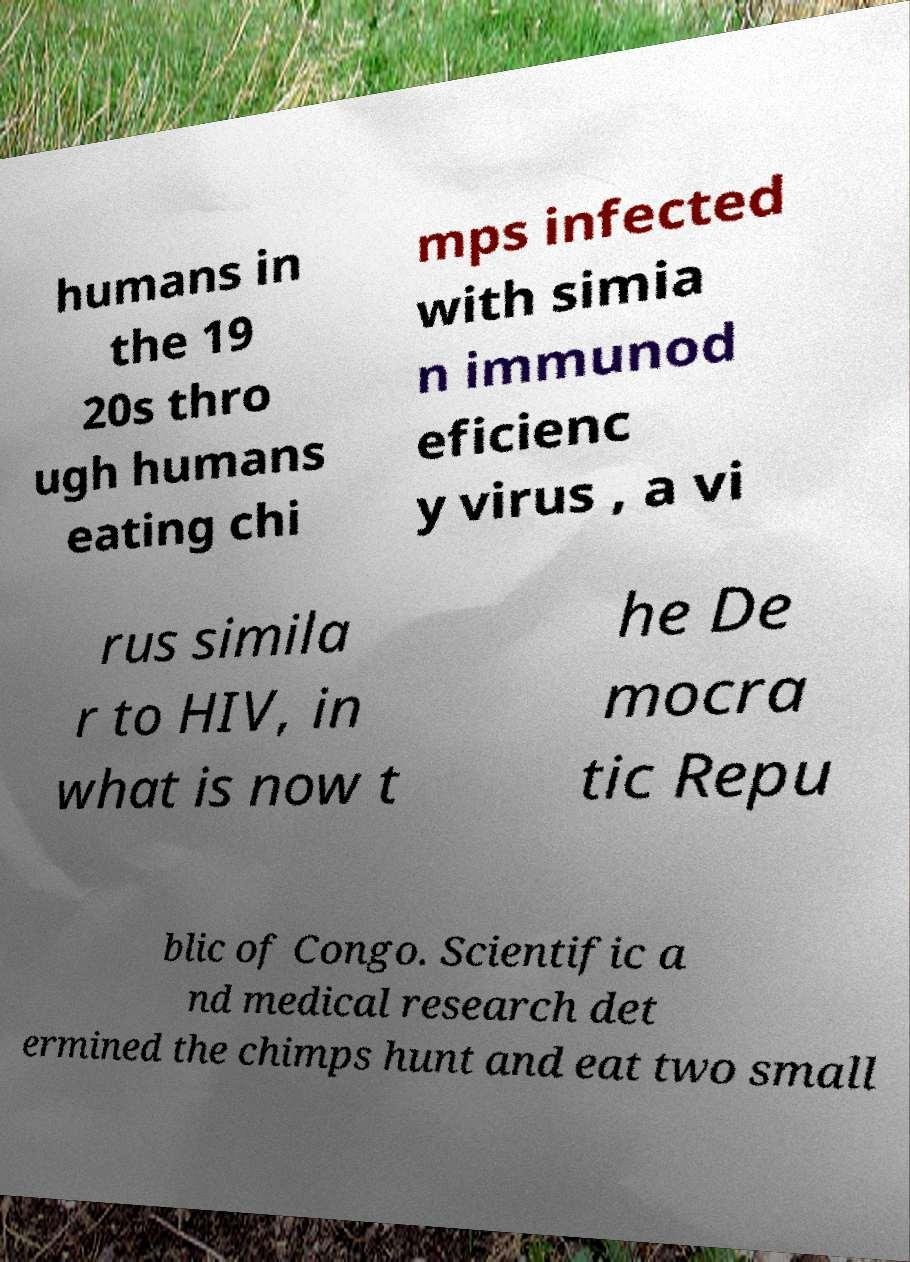Could you assist in decoding the text presented in this image and type it out clearly? humans in the 19 20s thro ugh humans eating chi mps infected with simia n immunod eficienc y virus , a vi rus simila r to HIV, in what is now t he De mocra tic Repu blic of Congo. Scientific a nd medical research det ermined the chimps hunt and eat two small 